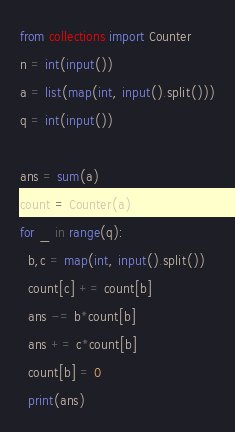Convert code to text. <code><loc_0><loc_0><loc_500><loc_500><_Python_>from collections import Counter
n = int(input())
a = list(map(int, input().split()))
q = int(input())

ans = sum(a)
count = Counter(a)
for _ in range(q):
  b,c = map(int, input().split())
  count[c] += count[b]
  ans -= b*count[b]
  ans += c*count[b]
  count[b] = 0
  print(ans)</code> 